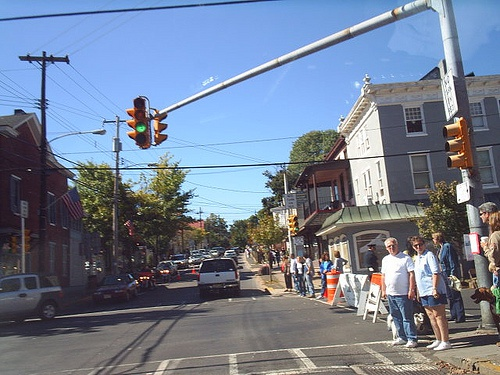Describe the objects in this image and their specific colors. I can see people in lightblue, white, darkgray, gray, and black tones, car in lightblue, black, and gray tones, people in lightblue, white, gray, and brown tones, people in lightblue, black, gray, and darkgray tones, and car in lightblue, black, gray, and darkgray tones in this image. 